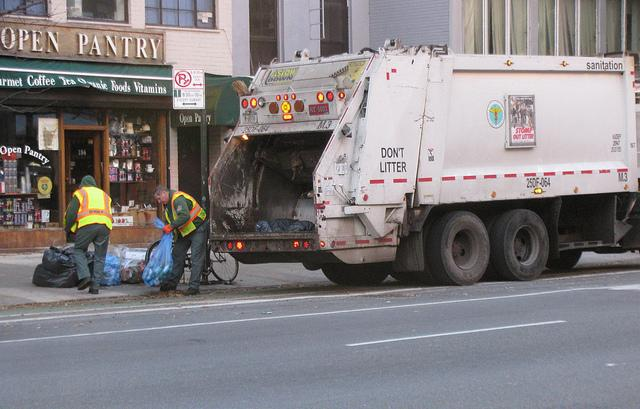Why are the men's vests yellow in color?

Choices:
A) fashion
B) dress code
C) visibility
D) camouflage visibility 